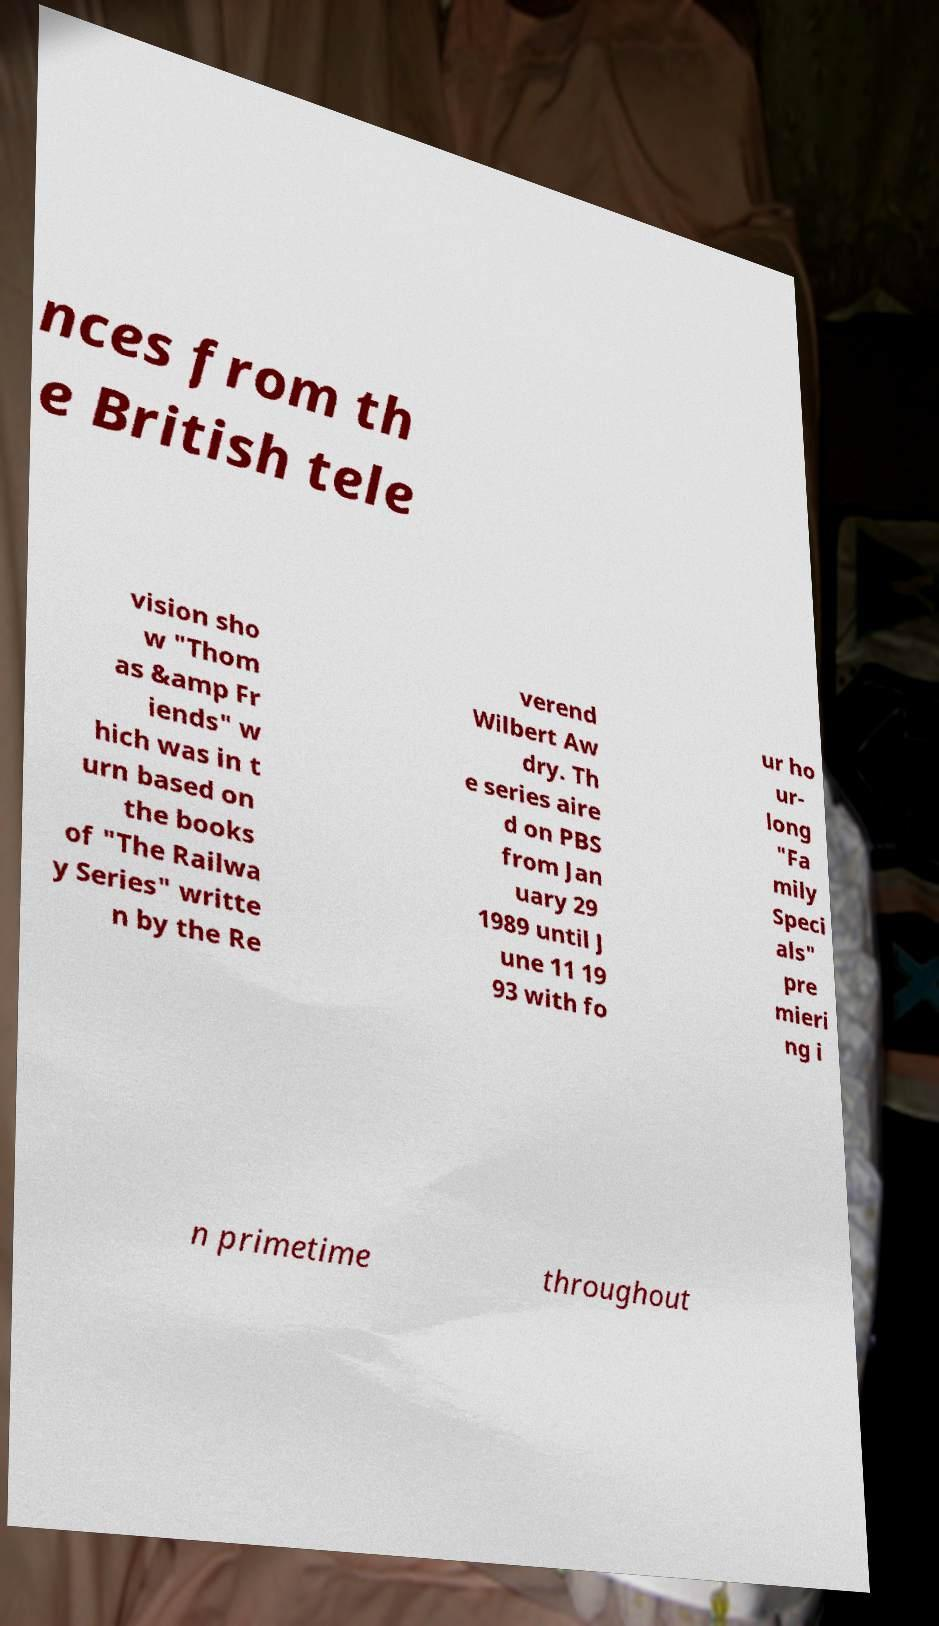There's text embedded in this image that I need extracted. Can you transcribe it verbatim? nces from th e British tele vision sho w "Thom as &amp Fr iends" w hich was in t urn based on the books of "The Railwa y Series" writte n by the Re verend Wilbert Aw dry. Th e series aire d on PBS from Jan uary 29 1989 until J une 11 19 93 with fo ur ho ur- long "Fa mily Speci als" pre mieri ng i n primetime throughout 